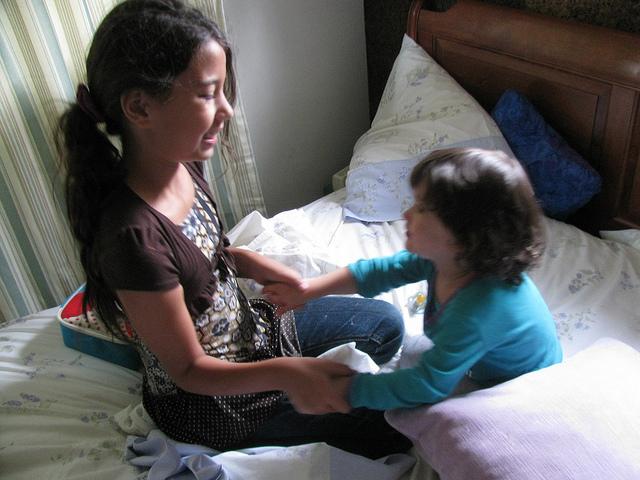Are the children playing?
Concise answer only. Yes. Is the bed made?
Concise answer only. No. Are these girls young?
Be succinct. Yes. 